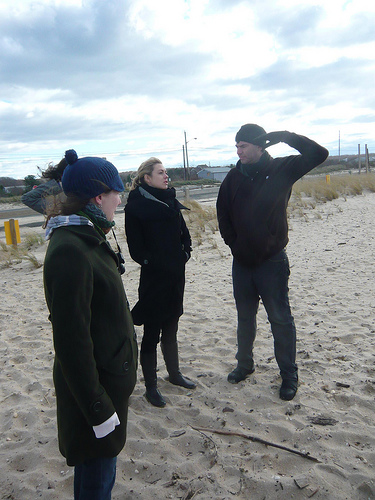<image>
Is there a man to the left of the woman? Yes. From this viewpoint, the man is positioned to the left side relative to the woman. 